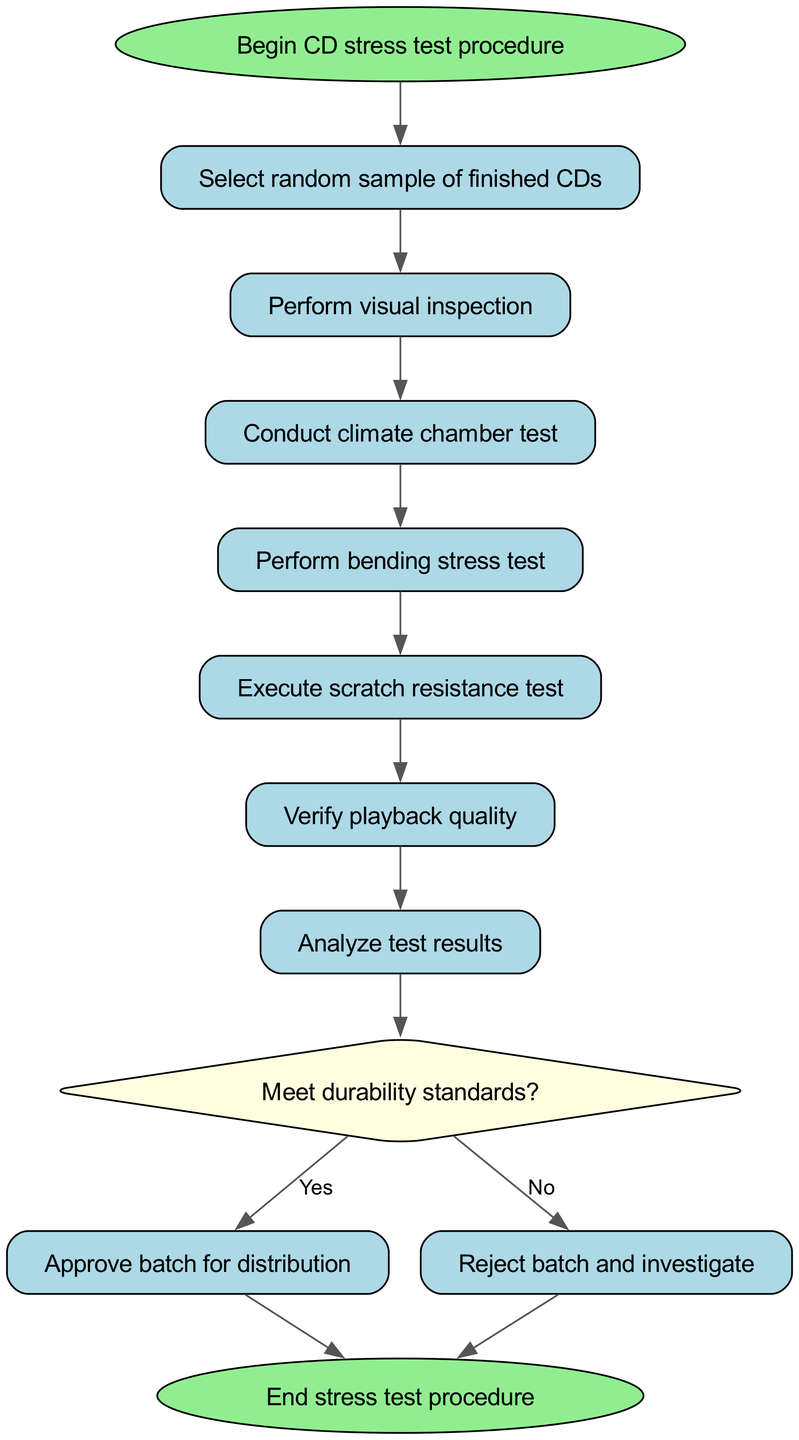What is the first step in the procedure? The first step in the diagram, represented by the node labeled "Begin CD stress test procedure," indicates the initiation of the process. This is the starting point of the entire flow.
Answer: Begin CD stress test procedure How many tests are conducted after the visual inspection? After the visual inspection, there are three tests conducted in sequence: the climate chamber test, the bending stress test, and the scratch resistance test. Therefore, the count is three.
Answer: 3 What happens if the CDs do not meet the durability standards? If the CDs do not meet the durability standards, the path leads to the node labeled "Reject batch and investigate." This indicates that the batch is not approved and further action is required.
Answer: Reject batch and investigate How many edges are connected to the "decision" node? The "decision" node connects to two edges: one leading to the "pass" node labeled "Yes" and another leading to the "fail" node labeled "No." Hence, the total count of edges connected to this node is two.
Answer: 2 What is the result of the final analysis step? The result of the "Analyze test results" step leads to the "decision" node, which assesses whether the CDs meet the durability standards. This is a critical point in determining the subsequent action.
Answer: decision What is the first test conducted after selecting the sample? After selecting a random sample of finished CDs, the first test that is conducted as per the diagram is the visual inspection. This is the immediate next step in the flow.
Answer: Perform visual inspection How does the procedure end if the batch passes quality checks? If the batch passes the quality checks, the procedure flows to the "Approve batch for distribution" node, resulting in the successful end of the testing process. The flow then ends from this point.
Answer: Approve batch for distribution Which tests are performed in sequence after the climate chamber test? After the climate chamber test, the sequence continues with the bending stress test followed by the scratch resistance test. Thus, these two tests are performed in this order.
Answer: bending stress test, scratch resistance test 